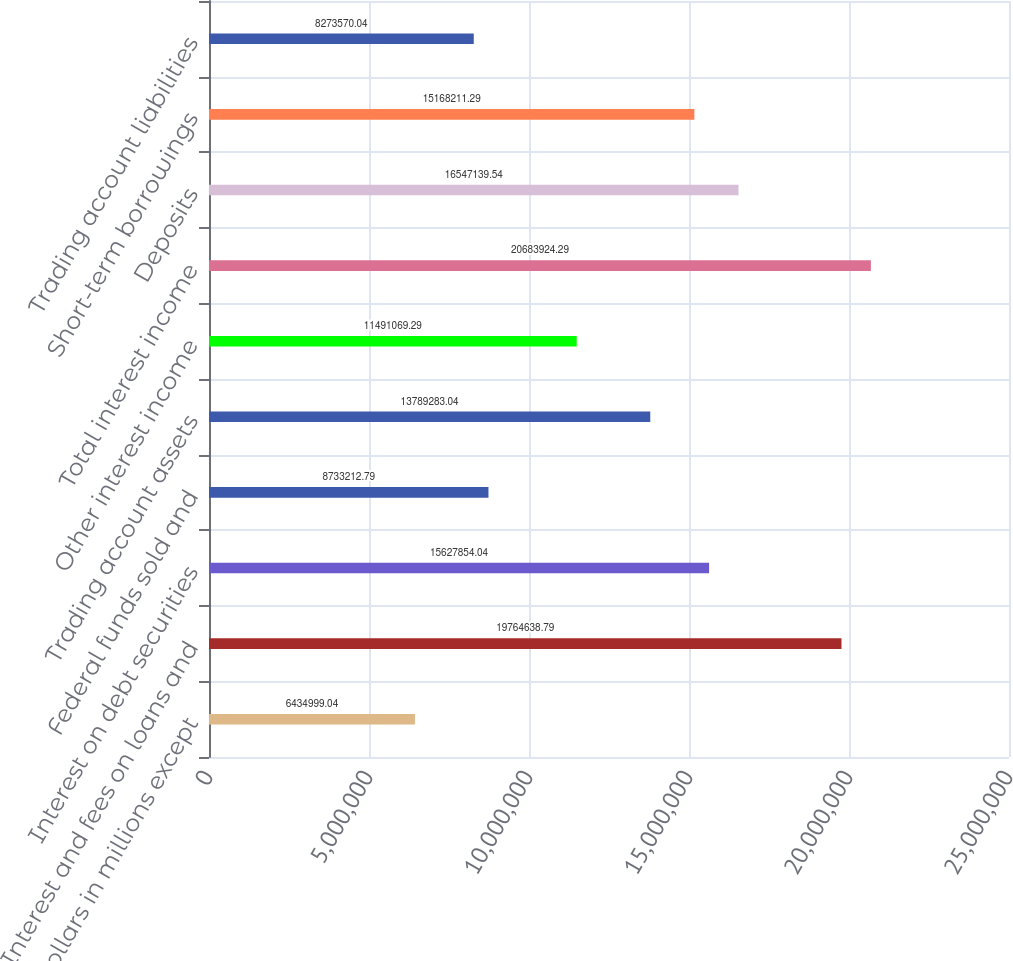<chart> <loc_0><loc_0><loc_500><loc_500><bar_chart><fcel>(Dollars in millions except<fcel>Interest and fees on loans and<fcel>Interest on debt securities<fcel>Federal funds sold and<fcel>Trading account assets<fcel>Other interest income<fcel>Total interest income<fcel>Deposits<fcel>Short-term borrowings<fcel>Trading account liabilities<nl><fcel>6.435e+06<fcel>1.97646e+07<fcel>1.56279e+07<fcel>8.73321e+06<fcel>1.37893e+07<fcel>1.14911e+07<fcel>2.06839e+07<fcel>1.65471e+07<fcel>1.51682e+07<fcel>8.27357e+06<nl></chart> 